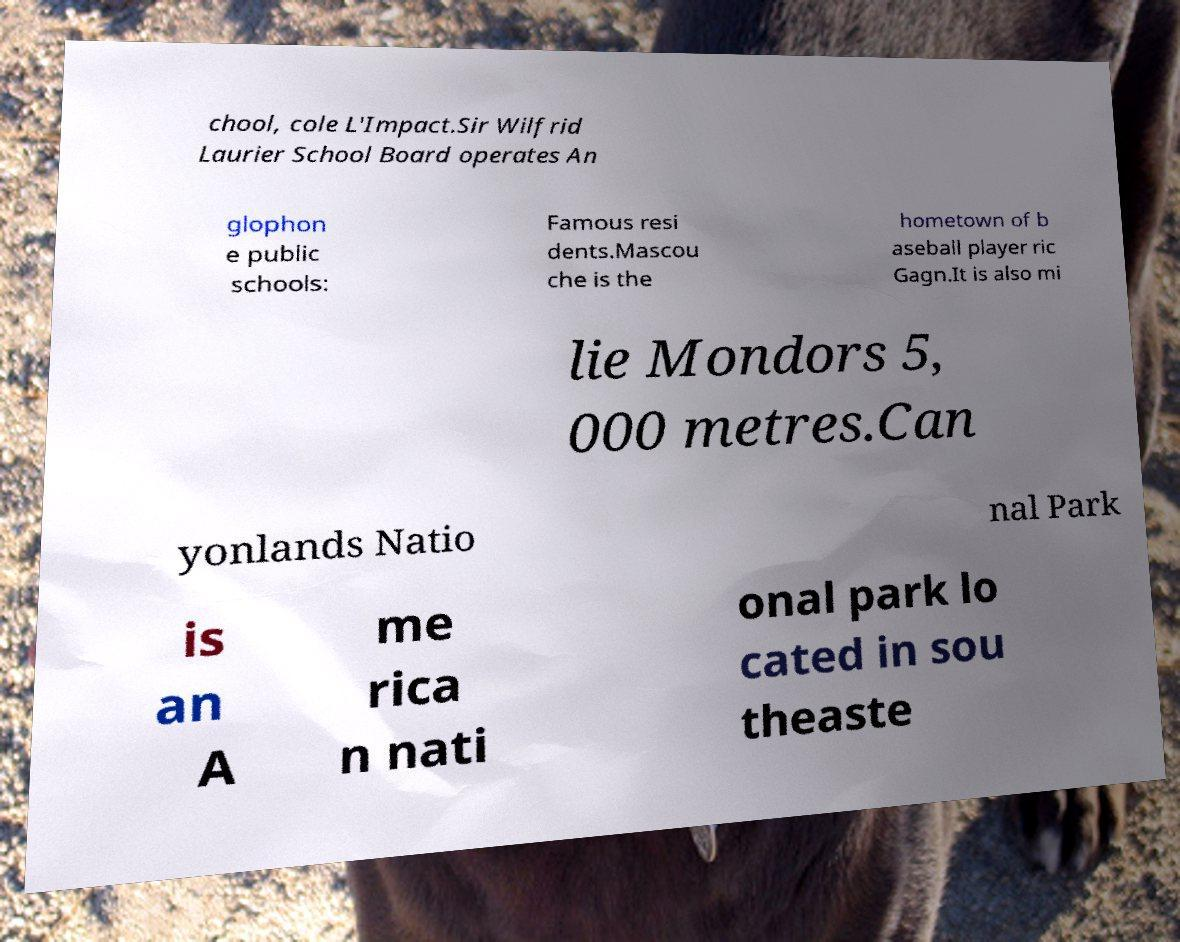I need the written content from this picture converted into text. Can you do that? chool, cole L'Impact.Sir Wilfrid Laurier School Board operates An glophon e public schools: Famous resi dents.Mascou che is the hometown of b aseball player ric Gagn.It is also mi lie Mondors 5, 000 metres.Can yonlands Natio nal Park is an A me rica n nati onal park lo cated in sou theaste 